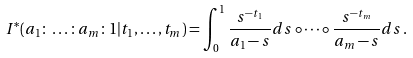Convert formula to latex. <formula><loc_0><loc_0><loc_500><loc_500>I ^ { * } ( a _ { 1 } \colon \dots \colon a _ { m } \colon 1 | t _ { 1 } , \dots , t _ { m } ) = \int _ { 0 } ^ { 1 } \frac { s ^ { - t _ { 1 } } } { a _ { 1 } - s } d s \circ \dots \circ \frac { s ^ { - t _ { m } } } { a _ { m } - s } d s \, .</formula> 